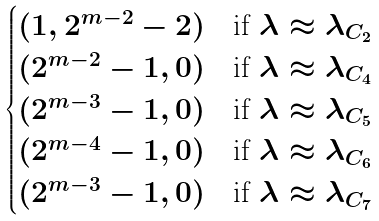<formula> <loc_0><loc_0><loc_500><loc_500>\begin{cases} ( 1 , 2 ^ { m - 2 } - 2 ) & \text {if $\lambda\approx \lambda_{C_{2}}$} \\ ( 2 ^ { m - 2 } - 1 , 0 ) & \text {if $\lambda\approx\lambda_{C_{4}}$} \\ ( 2 ^ { m - 3 } - 1 , 0 ) & \text {if $\lambda\approx\lambda_{C_{5}}$} \\ ( 2 ^ { m - 4 } - 1 , 0 ) & \text {if $\lambda\approx\lambda_{C_{6}}$} \\ ( 2 ^ { m - 3 } - 1 , 0 ) & \text {if $\lambda\approx\lambda_{C_{7}}$} \end{cases}</formula> 